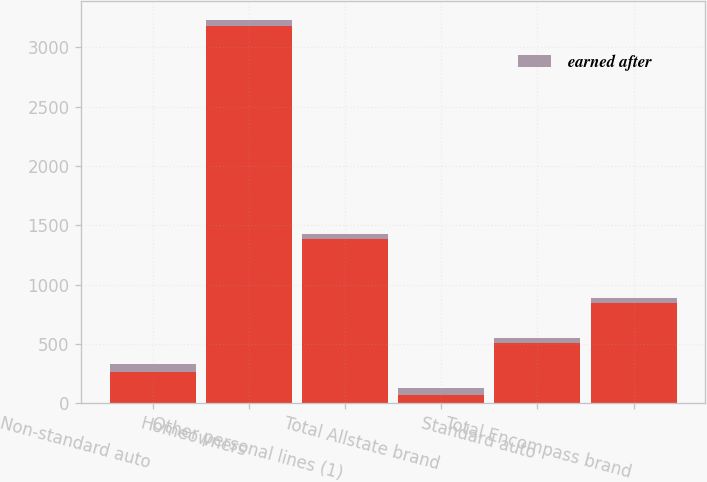<chart> <loc_0><loc_0><loc_500><loc_500><stacked_bar_chart><ecel><fcel>Non-standard auto<fcel>Homeowners<fcel>Other personal lines (1)<fcel>Total Allstate brand<fcel>Standard auto<fcel>Total Encompass brand<nl><fcel>nan<fcel>259<fcel>3182<fcel>1385<fcel>71.9<fcel>506<fcel>844<nl><fcel>earned after<fcel>71.9<fcel>43.9<fcel>39<fcel>57.6<fcel>44.6<fcel>44.8<nl></chart> 